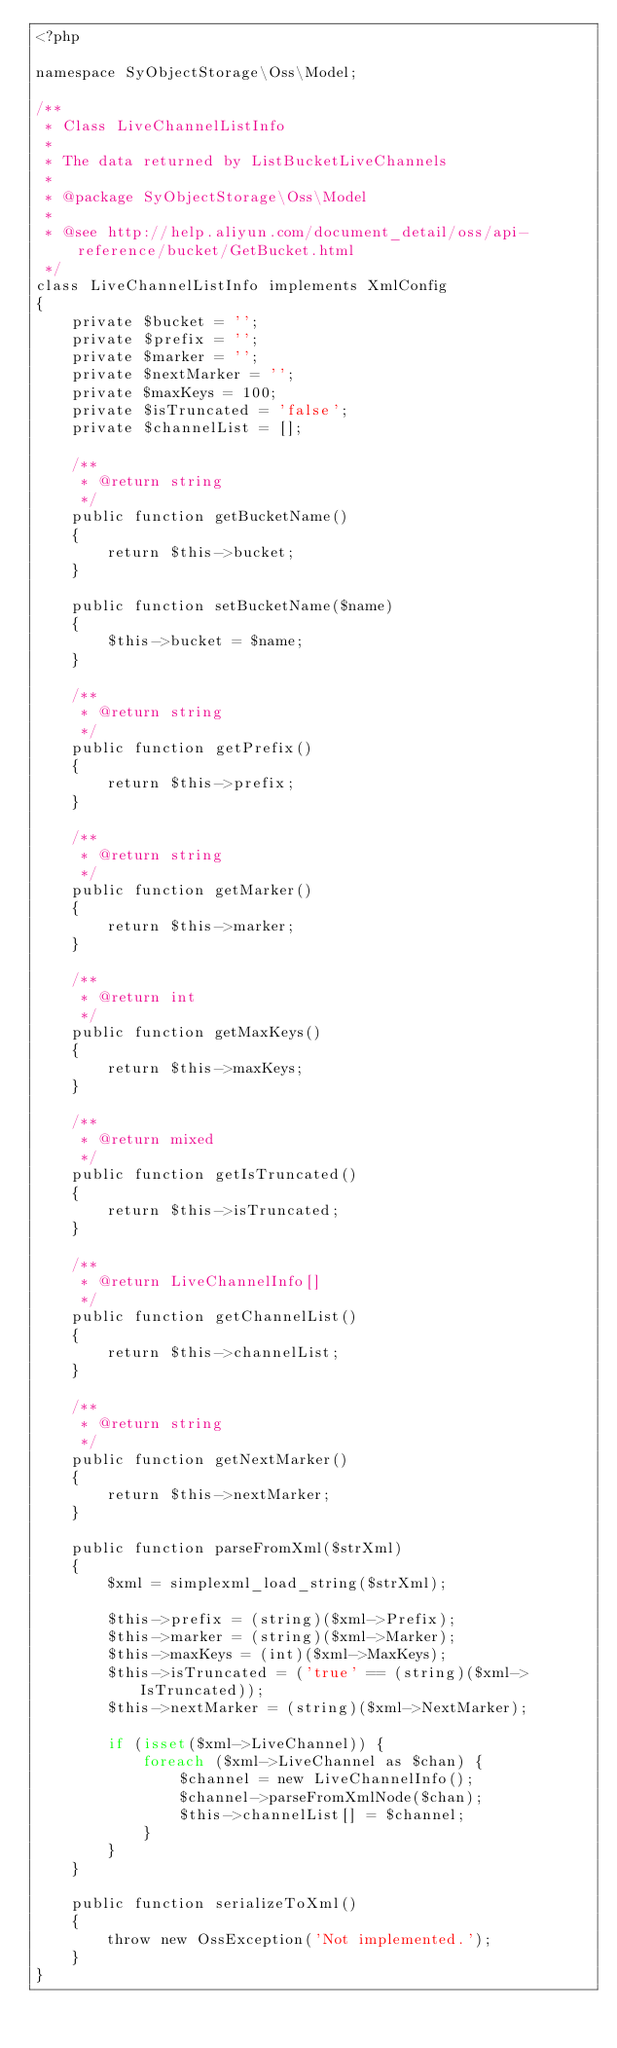Convert code to text. <code><loc_0><loc_0><loc_500><loc_500><_PHP_><?php

namespace SyObjectStorage\Oss\Model;

/**
 * Class LiveChannelListInfo
 *
 * The data returned by ListBucketLiveChannels
 *
 * @package SyObjectStorage\Oss\Model
 *
 * @see http://help.aliyun.com/document_detail/oss/api-reference/bucket/GetBucket.html
 */
class LiveChannelListInfo implements XmlConfig
{
    private $bucket = '';
    private $prefix = '';
    private $marker = '';
    private $nextMarker = '';
    private $maxKeys = 100;
    private $isTruncated = 'false';
    private $channelList = [];

    /**
     * @return string
     */
    public function getBucketName()
    {
        return $this->bucket;
    }

    public function setBucketName($name)
    {
        $this->bucket = $name;
    }

    /**
     * @return string
     */
    public function getPrefix()
    {
        return $this->prefix;
    }

    /**
     * @return string
     */
    public function getMarker()
    {
        return $this->marker;
    }

    /**
     * @return int
     */
    public function getMaxKeys()
    {
        return $this->maxKeys;
    }

    /**
     * @return mixed
     */
    public function getIsTruncated()
    {
        return $this->isTruncated;
    }

    /**
     * @return LiveChannelInfo[]
     */
    public function getChannelList()
    {
        return $this->channelList;
    }

    /**
     * @return string
     */
    public function getNextMarker()
    {
        return $this->nextMarker;
    }

    public function parseFromXml($strXml)
    {
        $xml = simplexml_load_string($strXml);

        $this->prefix = (string)($xml->Prefix);
        $this->marker = (string)($xml->Marker);
        $this->maxKeys = (int)($xml->MaxKeys);
        $this->isTruncated = ('true' == (string)($xml->IsTruncated));
        $this->nextMarker = (string)($xml->NextMarker);

        if (isset($xml->LiveChannel)) {
            foreach ($xml->LiveChannel as $chan) {
                $channel = new LiveChannelInfo();
                $channel->parseFromXmlNode($chan);
                $this->channelList[] = $channel;
            }
        }
    }

    public function serializeToXml()
    {
        throw new OssException('Not implemented.');
    }
}
</code> 